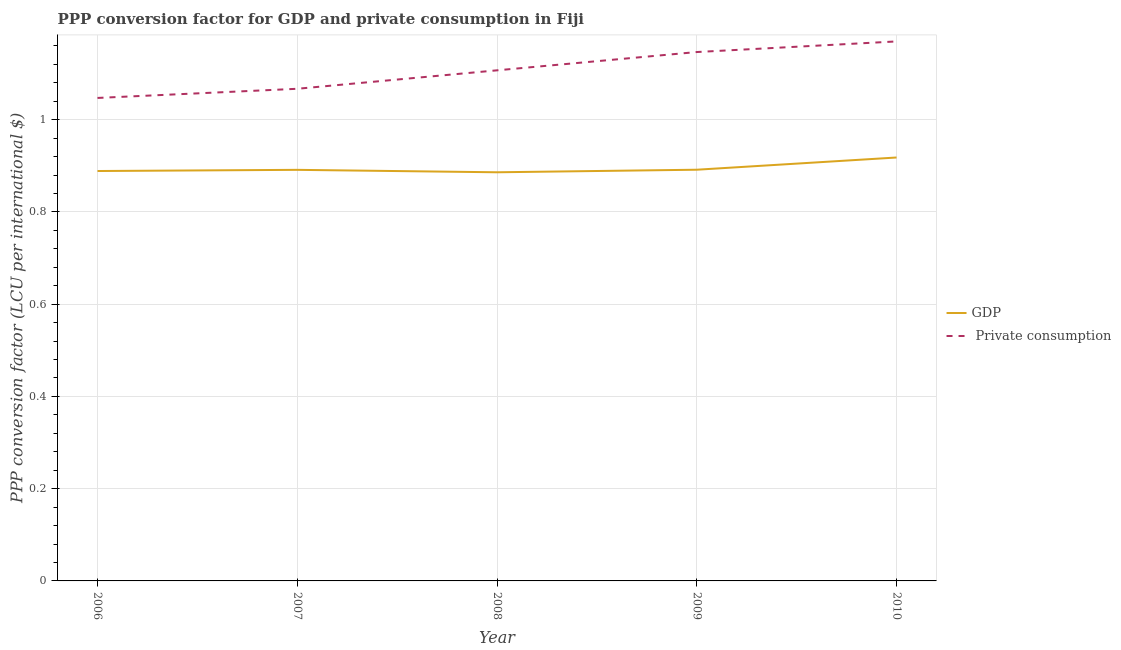How many different coloured lines are there?
Offer a terse response. 2. Does the line corresponding to ppp conversion factor for private consumption intersect with the line corresponding to ppp conversion factor for gdp?
Your response must be concise. No. What is the ppp conversion factor for private consumption in 2009?
Make the answer very short. 1.15. Across all years, what is the maximum ppp conversion factor for private consumption?
Make the answer very short. 1.17. Across all years, what is the minimum ppp conversion factor for private consumption?
Provide a succinct answer. 1.05. In which year was the ppp conversion factor for gdp maximum?
Your answer should be very brief. 2010. In which year was the ppp conversion factor for gdp minimum?
Your answer should be compact. 2008. What is the total ppp conversion factor for private consumption in the graph?
Keep it short and to the point. 5.54. What is the difference between the ppp conversion factor for private consumption in 2008 and that in 2009?
Your response must be concise. -0.04. What is the difference between the ppp conversion factor for gdp in 2010 and the ppp conversion factor for private consumption in 2009?
Provide a short and direct response. -0.23. What is the average ppp conversion factor for private consumption per year?
Provide a succinct answer. 1.11. In the year 2006, what is the difference between the ppp conversion factor for private consumption and ppp conversion factor for gdp?
Give a very brief answer. 0.16. What is the ratio of the ppp conversion factor for gdp in 2008 to that in 2010?
Offer a terse response. 0.97. What is the difference between the highest and the second highest ppp conversion factor for gdp?
Your answer should be very brief. 0.03. What is the difference between the highest and the lowest ppp conversion factor for private consumption?
Provide a succinct answer. 0.12. In how many years, is the ppp conversion factor for private consumption greater than the average ppp conversion factor for private consumption taken over all years?
Your answer should be compact. 2. Is the sum of the ppp conversion factor for gdp in 2009 and 2010 greater than the maximum ppp conversion factor for private consumption across all years?
Your answer should be very brief. Yes. Does the ppp conversion factor for private consumption monotonically increase over the years?
Offer a very short reply. Yes. Is the ppp conversion factor for gdp strictly greater than the ppp conversion factor for private consumption over the years?
Your response must be concise. No. Is the ppp conversion factor for gdp strictly less than the ppp conversion factor for private consumption over the years?
Offer a very short reply. Yes. How many lines are there?
Offer a terse response. 2. How many years are there in the graph?
Your response must be concise. 5. What is the difference between two consecutive major ticks on the Y-axis?
Provide a succinct answer. 0.2. Does the graph contain grids?
Ensure brevity in your answer.  Yes. What is the title of the graph?
Make the answer very short. PPP conversion factor for GDP and private consumption in Fiji. What is the label or title of the Y-axis?
Make the answer very short. PPP conversion factor (LCU per international $). What is the PPP conversion factor (LCU per international $) of GDP in 2006?
Ensure brevity in your answer.  0.89. What is the PPP conversion factor (LCU per international $) of  Private consumption in 2006?
Make the answer very short. 1.05. What is the PPP conversion factor (LCU per international $) in GDP in 2007?
Your response must be concise. 0.89. What is the PPP conversion factor (LCU per international $) in  Private consumption in 2007?
Ensure brevity in your answer.  1.07. What is the PPP conversion factor (LCU per international $) in GDP in 2008?
Give a very brief answer. 0.89. What is the PPP conversion factor (LCU per international $) of  Private consumption in 2008?
Provide a short and direct response. 1.11. What is the PPP conversion factor (LCU per international $) of GDP in 2009?
Your answer should be compact. 0.89. What is the PPP conversion factor (LCU per international $) of  Private consumption in 2009?
Offer a terse response. 1.15. What is the PPP conversion factor (LCU per international $) in GDP in 2010?
Provide a succinct answer. 0.92. What is the PPP conversion factor (LCU per international $) in  Private consumption in 2010?
Your answer should be very brief. 1.17. Across all years, what is the maximum PPP conversion factor (LCU per international $) in GDP?
Offer a terse response. 0.92. Across all years, what is the maximum PPP conversion factor (LCU per international $) in  Private consumption?
Offer a very short reply. 1.17. Across all years, what is the minimum PPP conversion factor (LCU per international $) of GDP?
Your response must be concise. 0.89. Across all years, what is the minimum PPP conversion factor (LCU per international $) in  Private consumption?
Keep it short and to the point. 1.05. What is the total PPP conversion factor (LCU per international $) of GDP in the graph?
Make the answer very short. 4.48. What is the total PPP conversion factor (LCU per international $) in  Private consumption in the graph?
Provide a succinct answer. 5.54. What is the difference between the PPP conversion factor (LCU per international $) of GDP in 2006 and that in 2007?
Your answer should be very brief. -0. What is the difference between the PPP conversion factor (LCU per international $) in  Private consumption in 2006 and that in 2007?
Provide a succinct answer. -0.02. What is the difference between the PPP conversion factor (LCU per international $) of GDP in 2006 and that in 2008?
Offer a very short reply. 0. What is the difference between the PPP conversion factor (LCU per international $) of  Private consumption in 2006 and that in 2008?
Ensure brevity in your answer.  -0.06. What is the difference between the PPP conversion factor (LCU per international $) of GDP in 2006 and that in 2009?
Offer a very short reply. -0. What is the difference between the PPP conversion factor (LCU per international $) of  Private consumption in 2006 and that in 2009?
Make the answer very short. -0.1. What is the difference between the PPP conversion factor (LCU per international $) in GDP in 2006 and that in 2010?
Offer a very short reply. -0.03. What is the difference between the PPP conversion factor (LCU per international $) in  Private consumption in 2006 and that in 2010?
Make the answer very short. -0.12. What is the difference between the PPP conversion factor (LCU per international $) of GDP in 2007 and that in 2008?
Provide a short and direct response. 0.01. What is the difference between the PPP conversion factor (LCU per international $) in  Private consumption in 2007 and that in 2008?
Your answer should be very brief. -0.04. What is the difference between the PPP conversion factor (LCU per international $) in GDP in 2007 and that in 2009?
Keep it short and to the point. -0. What is the difference between the PPP conversion factor (LCU per international $) of  Private consumption in 2007 and that in 2009?
Make the answer very short. -0.08. What is the difference between the PPP conversion factor (LCU per international $) of GDP in 2007 and that in 2010?
Keep it short and to the point. -0.03. What is the difference between the PPP conversion factor (LCU per international $) in  Private consumption in 2007 and that in 2010?
Provide a succinct answer. -0.1. What is the difference between the PPP conversion factor (LCU per international $) of GDP in 2008 and that in 2009?
Provide a succinct answer. -0.01. What is the difference between the PPP conversion factor (LCU per international $) in  Private consumption in 2008 and that in 2009?
Offer a terse response. -0.04. What is the difference between the PPP conversion factor (LCU per international $) of GDP in 2008 and that in 2010?
Give a very brief answer. -0.03. What is the difference between the PPP conversion factor (LCU per international $) of  Private consumption in 2008 and that in 2010?
Your answer should be compact. -0.06. What is the difference between the PPP conversion factor (LCU per international $) of GDP in 2009 and that in 2010?
Give a very brief answer. -0.03. What is the difference between the PPP conversion factor (LCU per international $) in  Private consumption in 2009 and that in 2010?
Your answer should be very brief. -0.02. What is the difference between the PPP conversion factor (LCU per international $) in GDP in 2006 and the PPP conversion factor (LCU per international $) in  Private consumption in 2007?
Keep it short and to the point. -0.18. What is the difference between the PPP conversion factor (LCU per international $) of GDP in 2006 and the PPP conversion factor (LCU per international $) of  Private consumption in 2008?
Make the answer very short. -0.22. What is the difference between the PPP conversion factor (LCU per international $) of GDP in 2006 and the PPP conversion factor (LCU per international $) of  Private consumption in 2009?
Provide a short and direct response. -0.26. What is the difference between the PPP conversion factor (LCU per international $) in GDP in 2006 and the PPP conversion factor (LCU per international $) in  Private consumption in 2010?
Offer a very short reply. -0.28. What is the difference between the PPP conversion factor (LCU per international $) in GDP in 2007 and the PPP conversion factor (LCU per international $) in  Private consumption in 2008?
Make the answer very short. -0.22. What is the difference between the PPP conversion factor (LCU per international $) in GDP in 2007 and the PPP conversion factor (LCU per international $) in  Private consumption in 2009?
Ensure brevity in your answer.  -0.26. What is the difference between the PPP conversion factor (LCU per international $) in GDP in 2007 and the PPP conversion factor (LCU per international $) in  Private consumption in 2010?
Offer a very short reply. -0.28. What is the difference between the PPP conversion factor (LCU per international $) of GDP in 2008 and the PPP conversion factor (LCU per international $) of  Private consumption in 2009?
Offer a very short reply. -0.26. What is the difference between the PPP conversion factor (LCU per international $) in GDP in 2008 and the PPP conversion factor (LCU per international $) in  Private consumption in 2010?
Your answer should be very brief. -0.28. What is the difference between the PPP conversion factor (LCU per international $) of GDP in 2009 and the PPP conversion factor (LCU per international $) of  Private consumption in 2010?
Your response must be concise. -0.28. What is the average PPP conversion factor (LCU per international $) in GDP per year?
Your answer should be compact. 0.9. What is the average PPP conversion factor (LCU per international $) of  Private consumption per year?
Provide a succinct answer. 1.11. In the year 2006, what is the difference between the PPP conversion factor (LCU per international $) in GDP and PPP conversion factor (LCU per international $) in  Private consumption?
Give a very brief answer. -0.16. In the year 2007, what is the difference between the PPP conversion factor (LCU per international $) in GDP and PPP conversion factor (LCU per international $) in  Private consumption?
Keep it short and to the point. -0.18. In the year 2008, what is the difference between the PPP conversion factor (LCU per international $) in GDP and PPP conversion factor (LCU per international $) in  Private consumption?
Give a very brief answer. -0.22. In the year 2009, what is the difference between the PPP conversion factor (LCU per international $) of GDP and PPP conversion factor (LCU per international $) of  Private consumption?
Ensure brevity in your answer.  -0.26. In the year 2010, what is the difference between the PPP conversion factor (LCU per international $) of GDP and PPP conversion factor (LCU per international $) of  Private consumption?
Make the answer very short. -0.25. What is the ratio of the PPP conversion factor (LCU per international $) of  Private consumption in 2006 to that in 2007?
Your answer should be compact. 0.98. What is the ratio of the PPP conversion factor (LCU per international $) of GDP in 2006 to that in 2008?
Your response must be concise. 1. What is the ratio of the PPP conversion factor (LCU per international $) of  Private consumption in 2006 to that in 2008?
Offer a very short reply. 0.95. What is the ratio of the PPP conversion factor (LCU per international $) of  Private consumption in 2006 to that in 2009?
Your answer should be very brief. 0.91. What is the ratio of the PPP conversion factor (LCU per international $) of GDP in 2006 to that in 2010?
Offer a terse response. 0.97. What is the ratio of the PPP conversion factor (LCU per international $) in  Private consumption in 2006 to that in 2010?
Give a very brief answer. 0.9. What is the ratio of the PPP conversion factor (LCU per international $) of GDP in 2007 to that in 2008?
Your answer should be compact. 1.01. What is the ratio of the PPP conversion factor (LCU per international $) in  Private consumption in 2007 to that in 2008?
Your answer should be compact. 0.96. What is the ratio of the PPP conversion factor (LCU per international $) of  Private consumption in 2007 to that in 2009?
Offer a terse response. 0.93. What is the ratio of the PPP conversion factor (LCU per international $) in GDP in 2007 to that in 2010?
Keep it short and to the point. 0.97. What is the ratio of the PPP conversion factor (LCU per international $) of  Private consumption in 2007 to that in 2010?
Offer a very short reply. 0.91. What is the ratio of the PPP conversion factor (LCU per international $) in  Private consumption in 2008 to that in 2009?
Keep it short and to the point. 0.97. What is the ratio of the PPP conversion factor (LCU per international $) of GDP in 2008 to that in 2010?
Your answer should be compact. 0.97. What is the ratio of the PPP conversion factor (LCU per international $) in  Private consumption in 2008 to that in 2010?
Give a very brief answer. 0.95. What is the ratio of the PPP conversion factor (LCU per international $) in GDP in 2009 to that in 2010?
Provide a succinct answer. 0.97. What is the ratio of the PPP conversion factor (LCU per international $) of  Private consumption in 2009 to that in 2010?
Offer a terse response. 0.98. What is the difference between the highest and the second highest PPP conversion factor (LCU per international $) in GDP?
Offer a very short reply. 0.03. What is the difference between the highest and the second highest PPP conversion factor (LCU per international $) in  Private consumption?
Your answer should be very brief. 0.02. What is the difference between the highest and the lowest PPP conversion factor (LCU per international $) in GDP?
Offer a terse response. 0.03. What is the difference between the highest and the lowest PPP conversion factor (LCU per international $) in  Private consumption?
Ensure brevity in your answer.  0.12. 